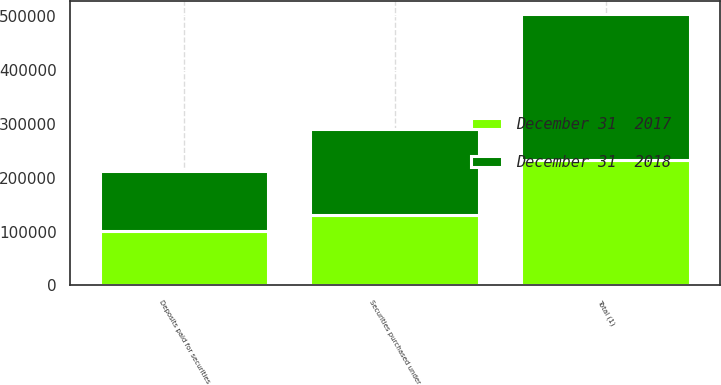Convert chart to OTSL. <chart><loc_0><loc_0><loc_500><loc_500><stacked_bar_chart><ecel><fcel>Securities purchased under<fcel>Deposits paid for securities<fcel>Total (1)<nl><fcel>December 31  2018<fcel>159364<fcel>111320<fcel>270684<nl><fcel>December 31  2017<fcel>130984<fcel>101494<fcel>232478<nl></chart> 